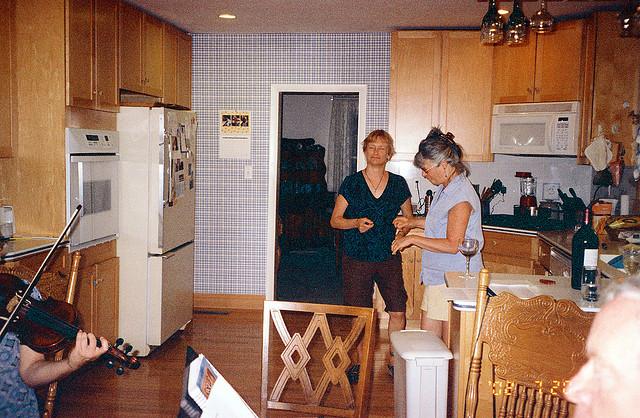Is it likely someone will be part of a recital some day?
Concise answer only. Yes. What is the wall treatment on the back wall?
Give a very brief answer. Wallpaper. Is this a modern picture?
Write a very short answer. No. 